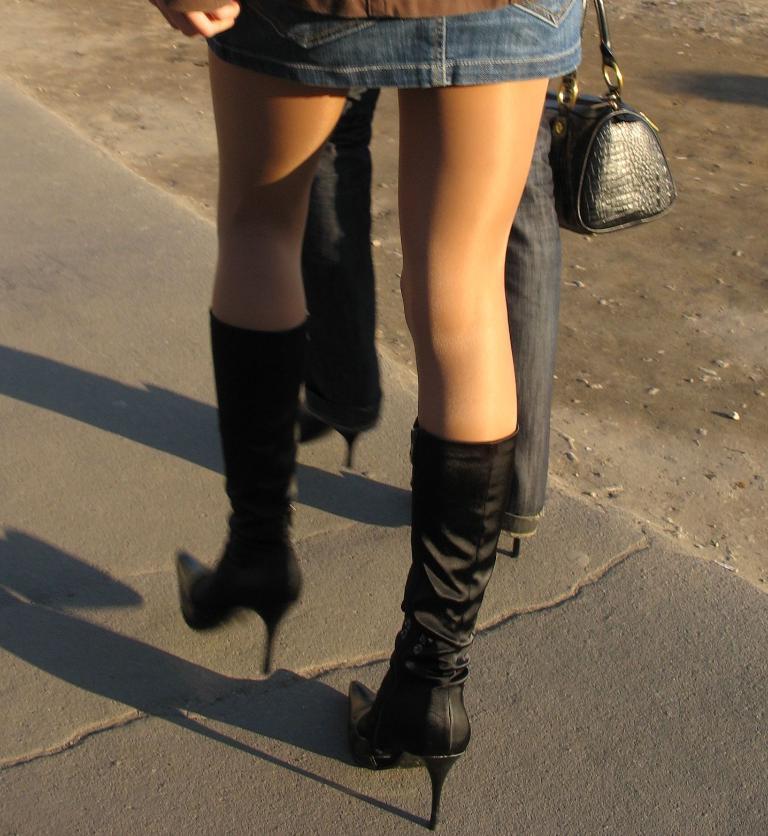Describe this image in one or two sentences. In this image I see person's legs and they are wearing heels and I see a bag over here and they're on the path. 